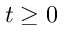<formula> <loc_0><loc_0><loc_500><loc_500>t \geq 0</formula> 